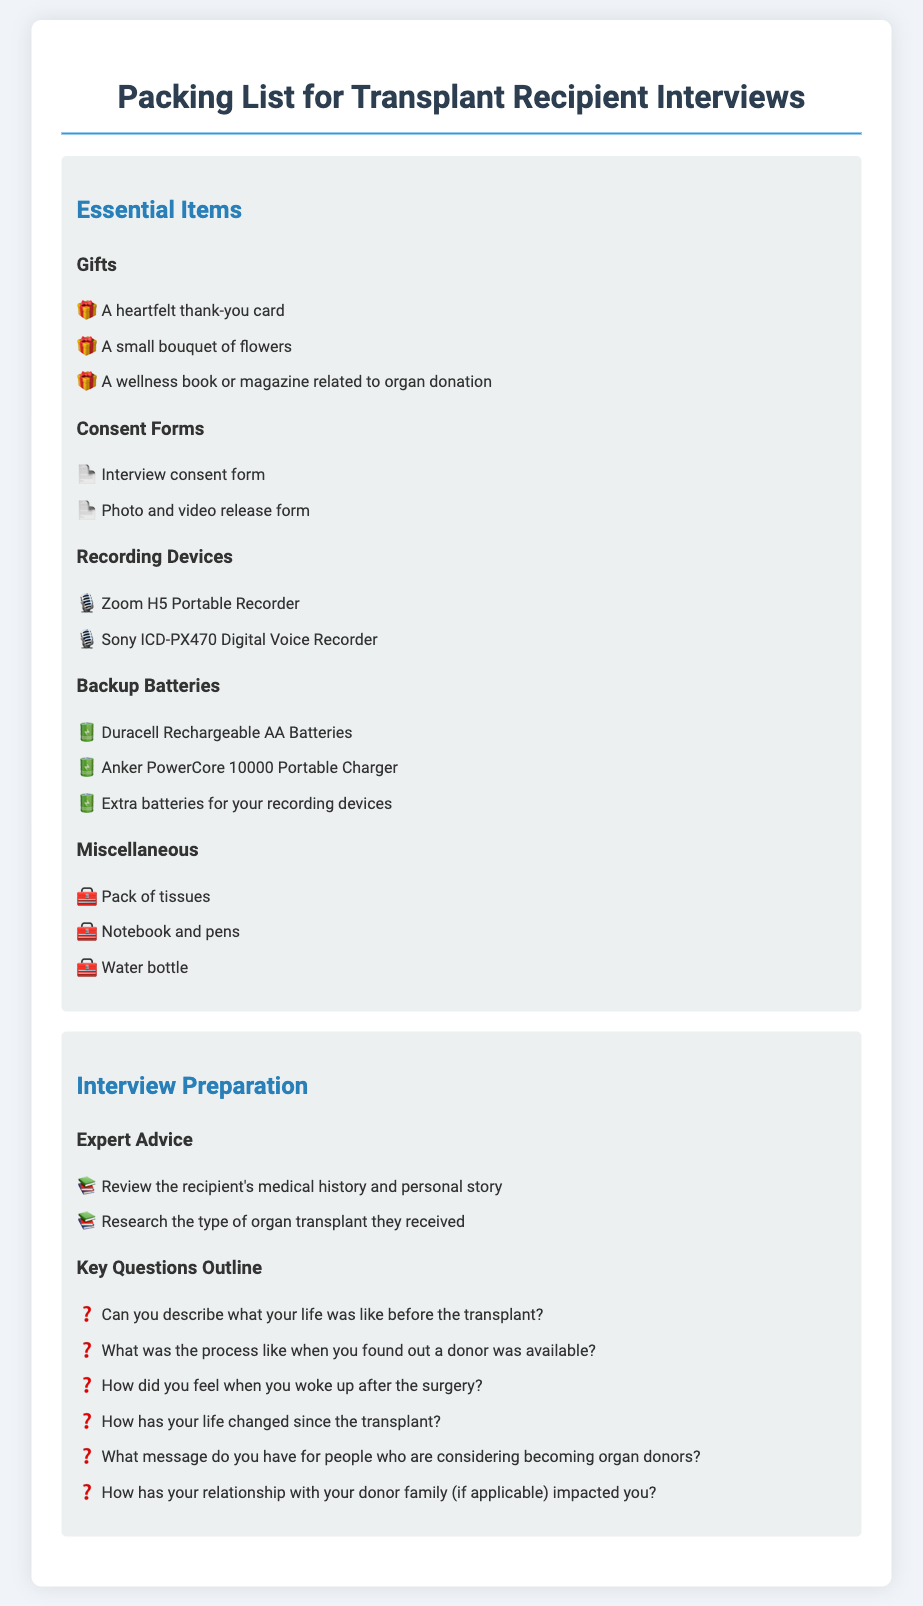What is the title of the document? The title of the document is located at the top of the rendered HTML and is styled accordingly.
Answer: Packing List for Transplant Recipient Interviews How many key questions are outlined for interviews? The number of key questions is listed in the "Key Questions Outline" section of the document.
Answer: Six What types of gifts are suggested for transplant recipient interviews? The document lists specific examples of gifts in the "Gifts" section, categorizing them clearly.
Answer: A heartfelt thank-you card, a small bouquet of flowers, a wellness book or magazine related to organ donation Which device is suggested as a recording device? The document explicitly mentions recommended recording devices under the "Recording Devices" section.
Answer: Zoom H5 Portable Recorder What is one item listed under Backup Batteries? The document lists various items under the "Backup Batteries" section, specifically designed for ensuring recording devices function properly.
Answer: Duracell Rechargeable AA Batteries What is included in the Miscellaneous preparation? Items in the "Miscellaneous" section are categorized to assist with comfort and convenience during interviews.
Answer: Pack of tissues What is one aspect to review in interview preparation? The "Interview Preparation" section provides insights on key elements to understand before conducting an interview.
Answer: Review the recipient's medical history and personal story How does the document facilitate organizing an interview? The document is structured with headings and sections that organize important items for the interview process.
Answer: Packing list 